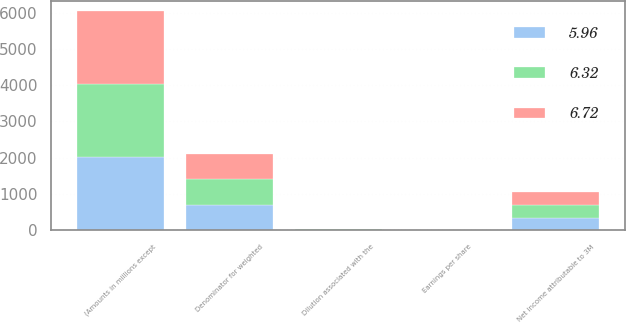<chart> <loc_0><loc_0><loc_500><loc_500><stacked_bar_chart><ecel><fcel>(Amounts in millions except<fcel>Net income attributable to 3M<fcel>Denominator for weighted<fcel>Dilution associated with the<fcel>Earnings per share<nl><fcel>6.72<fcel>2013<fcel>346.8<fcel>693.6<fcel>11.7<fcel>6.72<nl><fcel>5.96<fcel>2012<fcel>346.8<fcel>703.3<fcel>9.4<fcel>6.32<nl><fcel>6.32<fcel>2011<fcel>346.8<fcel>719<fcel>10.5<fcel>5.96<nl></chart> 